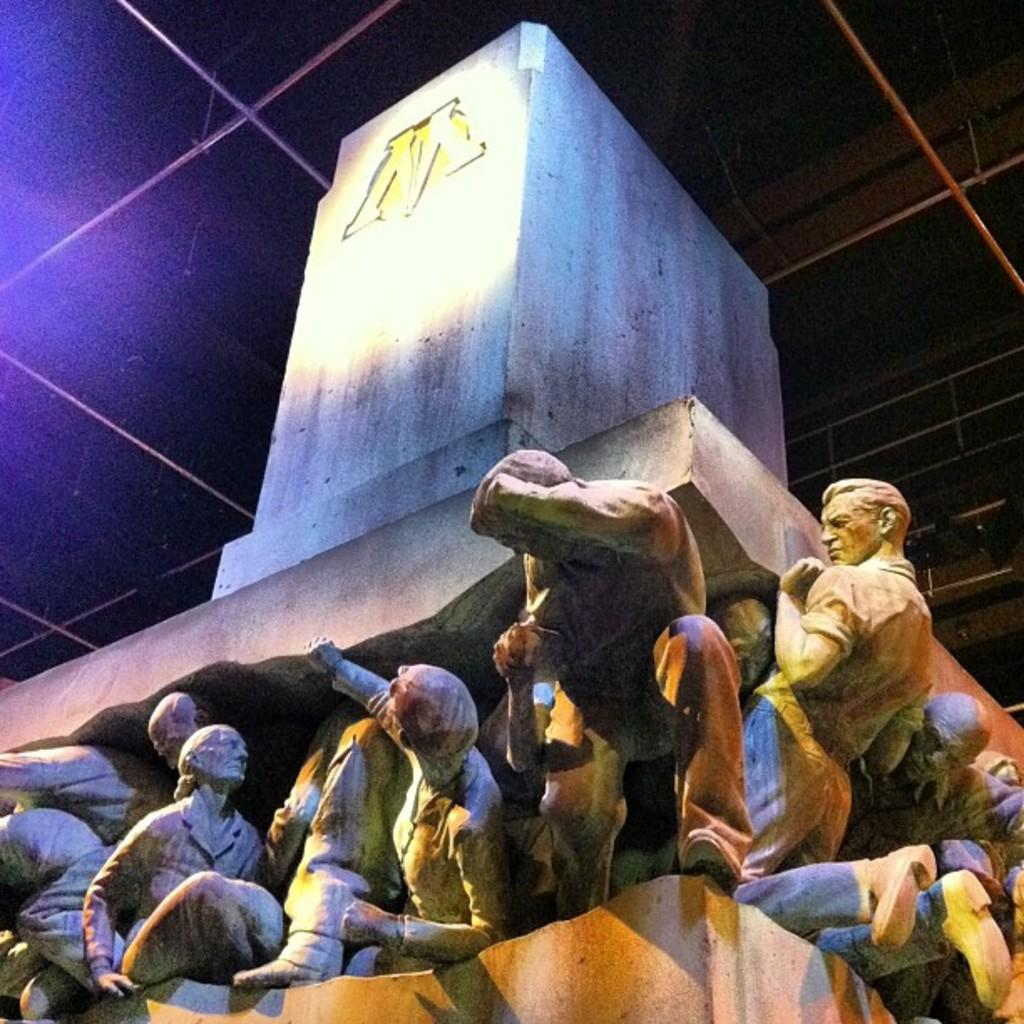What type of art is present in the image? There are sculptures in the image. What type of meal is being prepared in the image? There is no meal being prepared in the image; it only features sculptures. What material is the sun made of in the image? There is no sun present in the image, so it is not possible to determine the material it might be made of. 